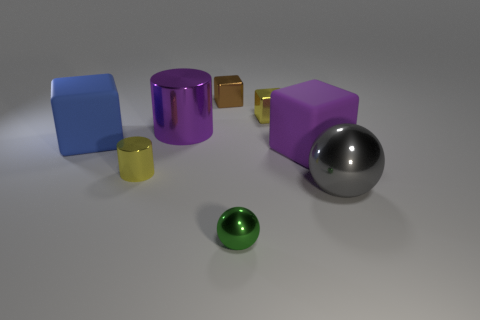There is a big shiny cylinder; is its color the same as the large matte block right of the tiny sphere?
Keep it short and to the point. Yes. There is a yellow object that is in front of the purple shiny cylinder; what is its material?
Your response must be concise. Metal. Is there a large shiny sphere that has the same color as the large metal cylinder?
Your answer should be very brief. No. The sphere that is the same size as the brown block is what color?
Offer a terse response. Green. How many tiny things are green things or purple metal cylinders?
Your answer should be very brief. 1. Is the number of tiny green things that are behind the blue block the same as the number of blue rubber blocks that are behind the purple metal object?
Your answer should be compact. Yes. What number of other rubber blocks have the same size as the blue rubber cube?
Make the answer very short. 1. What number of gray objects are big metallic objects or tiny metallic cubes?
Provide a short and direct response. 1. Are there an equal number of metal cylinders in front of the big purple block and large red rubber blocks?
Your response must be concise. No. There is a purple thing on the right side of the tiny green shiny thing; what size is it?
Provide a succinct answer. Large. 